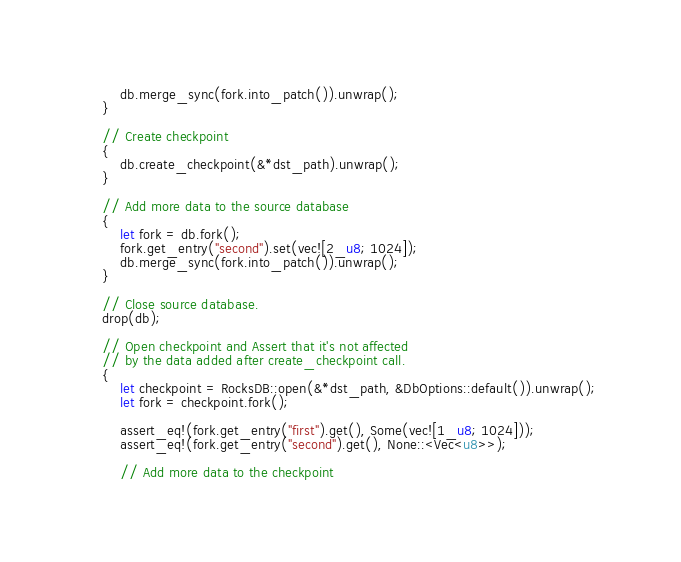Convert code to text. <code><loc_0><loc_0><loc_500><loc_500><_Rust_>        db.merge_sync(fork.into_patch()).unwrap();
    }

    // Create checkpoint
    {
        db.create_checkpoint(&*dst_path).unwrap();
    }

    // Add more data to the source database
    {
        let fork = db.fork();
        fork.get_entry("second").set(vec![2_u8; 1024]);
        db.merge_sync(fork.into_patch()).unwrap();
    }

    // Close source database.
    drop(db);

    // Open checkpoint and Assert that it's not affected
    // by the data added after create_checkpoint call.
    {
        let checkpoint = RocksDB::open(&*dst_path, &DbOptions::default()).unwrap();
        let fork = checkpoint.fork();

        assert_eq!(fork.get_entry("first").get(), Some(vec![1_u8; 1024]));
        assert_eq!(fork.get_entry("second").get(), None::<Vec<u8>>);

        // Add more data to the checkpoint</code> 